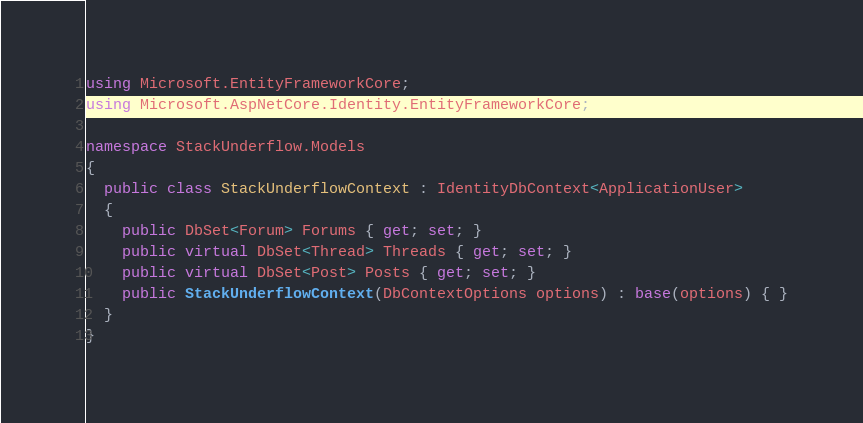Convert code to text. <code><loc_0><loc_0><loc_500><loc_500><_C#_>using Microsoft.EntityFrameworkCore;
using Microsoft.AspNetCore.Identity.EntityFrameworkCore;

namespace StackUnderflow.Models
{
  public class StackUnderflowContext : IdentityDbContext<ApplicationUser>
  {
    public DbSet<Forum> Forums { get; set; }
    public virtual DbSet<Thread> Threads { get; set; }
    public virtual DbSet<Post> Posts { get; set; }
    public StackUnderflowContext(DbContextOptions options) : base(options) { }
  }
}</code> 